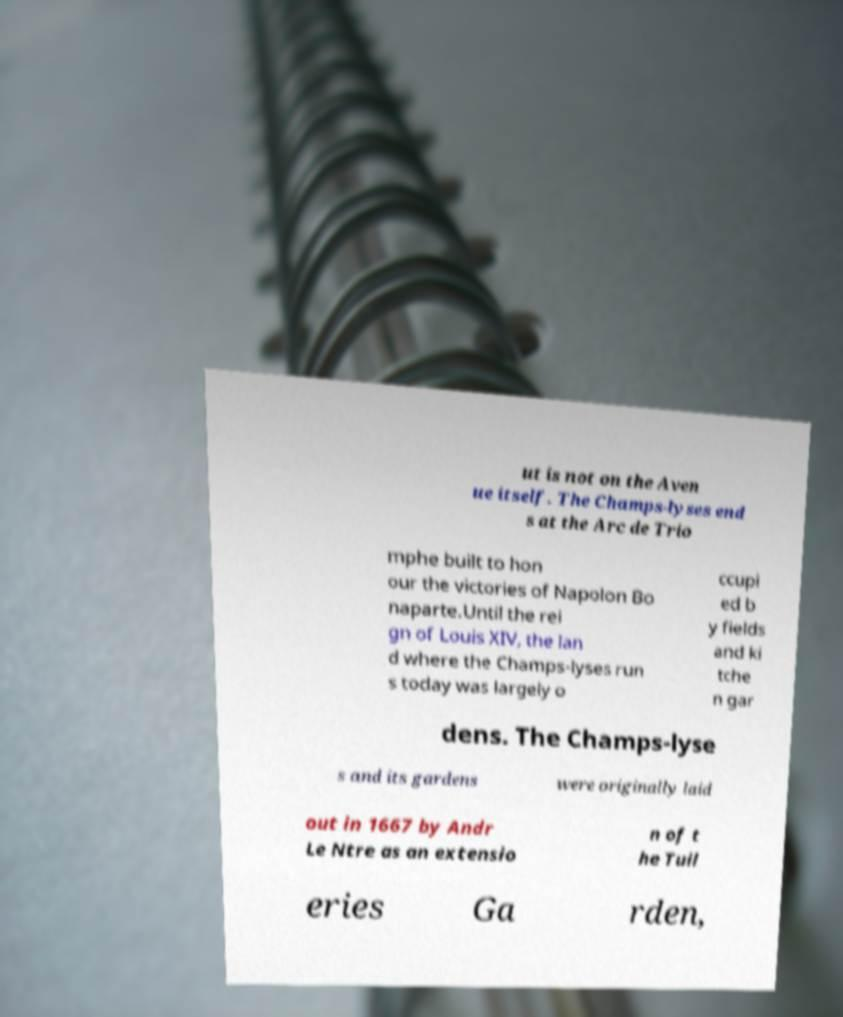What messages or text are displayed in this image? I need them in a readable, typed format. ut is not on the Aven ue itself. The Champs-lyses end s at the Arc de Trio mphe built to hon our the victories of Napolon Bo naparte.Until the rei gn of Louis XIV, the lan d where the Champs-lyses run s today was largely o ccupi ed b y fields and ki tche n gar dens. The Champs-lyse s and its gardens were originally laid out in 1667 by Andr Le Ntre as an extensio n of t he Tuil eries Ga rden, 